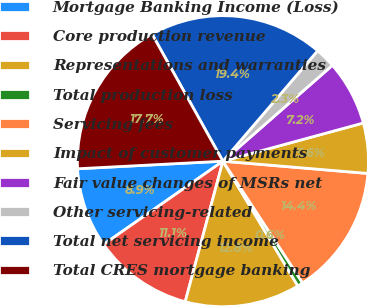<chart> <loc_0><loc_0><loc_500><loc_500><pie_chart><fcel>Mortgage Banking Income (Loss)<fcel>Core production revenue<fcel>Representations and warranties<fcel>Total production loss<fcel>Servicing fees<fcel>Impact of customer payments<fcel>Fair value changes of MSRs net<fcel>Other servicing-related<fcel>Total net servicing income<fcel>Total CRES mortgage banking<nl><fcel>8.87%<fcel>11.13%<fcel>12.78%<fcel>0.62%<fcel>14.43%<fcel>5.57%<fcel>7.22%<fcel>2.27%<fcel>19.38%<fcel>17.73%<nl></chart> 